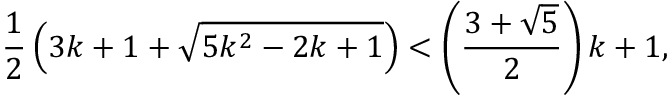<formula> <loc_0><loc_0><loc_500><loc_500>{ \frac { 1 } { 2 } } \left ( 3 k + 1 + { \sqrt { 5 k ^ { 2 } - 2 k + 1 } } \right ) < \left ( { \frac { 3 + { \sqrt { 5 } } } { 2 } } \right ) k + 1 ,</formula> 